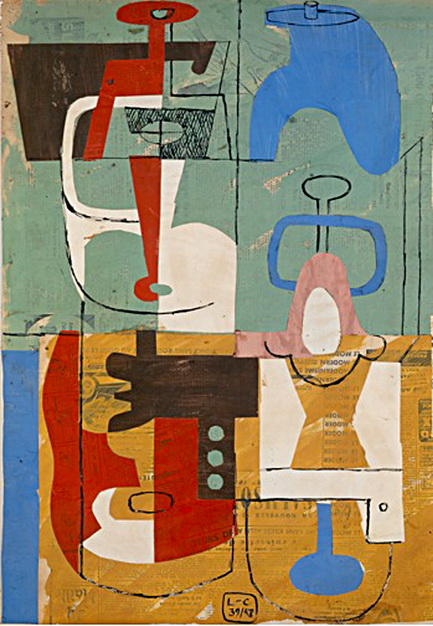How does the use of colors contribute to the overall impact of the artwork? The use of colors in this artwork plays a crucial role in its overall impact. The vibrant hues of blue, red, orange, and white catch the viewer’s eye and create a sense of dynamism and energy. The colors are strategically distributed across the canvas, ensuring that each section stands out while contributing to the cohesive whole. The calming blue and green background adds depth and contrast, enhancing the vividness of the foreground elements.

By juxtaposing different colors, the artist creates a rhythm and balance that guides the viewer’s gaze across the artwork. The interplay of light and dark tones adds to the visual appeal, making the composition more engaging and intriguing. 